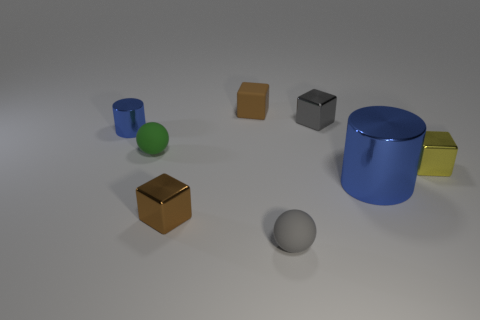There is a metallic thing that is both behind the yellow metallic object and to the right of the tiny blue cylinder; what is its size?
Provide a succinct answer. Small. What number of matte things are either green balls or big blue cubes?
Give a very brief answer. 1. There is a small brown thing in front of the big cylinder; is it the same shape as the blue shiny object that is left of the brown matte block?
Your response must be concise. No. Is there a green object that has the same material as the gray block?
Your response must be concise. No. The small shiny cylinder has what color?
Give a very brief answer. Blue. There is a brown thing behind the small blue cylinder; how big is it?
Offer a terse response. Small. How many small things are the same color as the tiny cylinder?
Ensure brevity in your answer.  0. There is a small ball behind the yellow block; is there a yellow shiny thing in front of it?
Offer a very short reply. Yes. There is a small rubber ball on the left side of the brown matte cube; is it the same color as the cylinder that is to the left of the big blue cylinder?
Provide a succinct answer. No. There is a rubber cube that is the same size as the gray rubber thing; what is its color?
Make the answer very short. Brown. 